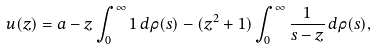Convert formula to latex. <formula><loc_0><loc_0><loc_500><loc_500>u ( z ) = a - z \int _ { 0 } ^ { \infty } 1 \, d \rho ( s ) - ( z ^ { 2 } + 1 ) \int _ { 0 } ^ { \infty } \frac { 1 } { s - z } \, d \rho ( s ) ,</formula> 